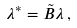<formula> <loc_0><loc_0><loc_500><loc_500>\lambda ^ { * } = \tilde { B } \lambda \, ,</formula> 